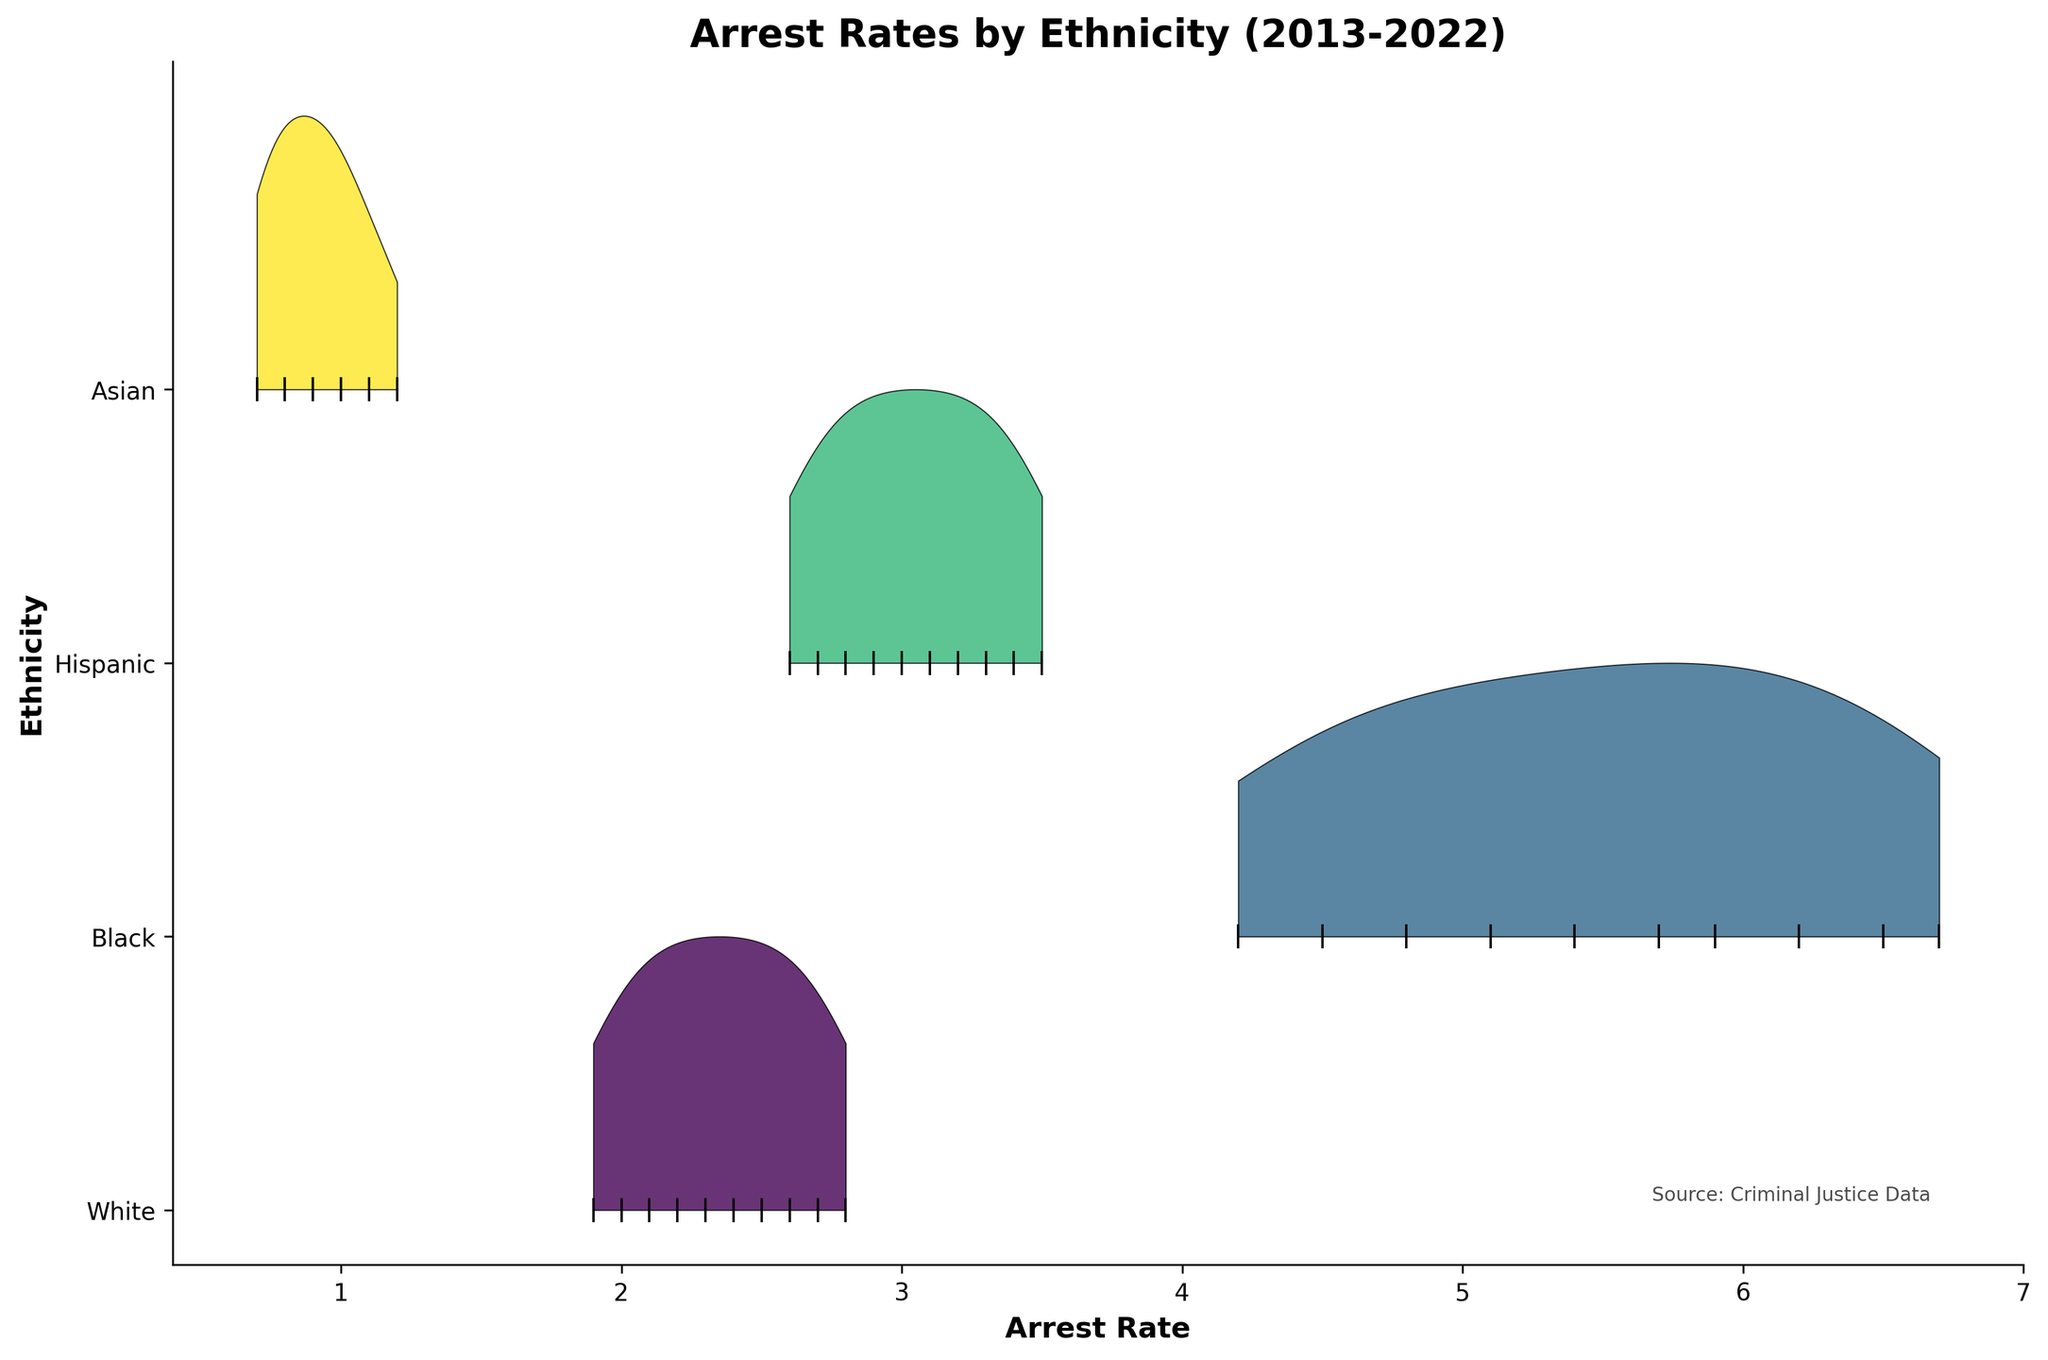What is the title of the figure? The title of the figure is displayed prominently at the top and serves as a summary of what the plot represents.
Answer: Arrest Rates by Ethnicity (2013-2022) How many ethnic groups are represented in the plot? By counting the number of unique labels on the y-axis, you can determine the number of different ethnic groups represented in the plot.
Answer: Four Which ethnic group has the highest arrest rate in 2022? By locating the year 2022 on the x-axis and checking which ethnic group has the highest arrest rate, you can identify the required group.
Answer: Black What is the arrest rate range for Hispanic ethnicity across the years? By examining the plot for the Hispanic group, you can observe the minimum and maximum arrest rates over the years.
Answer: 2.6 to 3.5 Between which years did the Black ethnic group experience the most significant decrease in arrest rates? By looking at the trend for the Black ethnic group's arrest rates on the plot, you can identify the year period with the steepest decline.
Answer: 2013 to 2014 Which ethnic group has observed the lowest variability in arrest rates over the decade? By examining the width and spread of the ridgeline plot for each ethnic group, you can conclude which has the least variability.
Answer: Asian What is the difference in arrest rates between Whites and Blacks in 2020? Locate the arrest rates for Whites and Blacks in 2020 on the plot and subtract the arrest rate for Whites from that for Blacks.
Answer: 4.8 - 2.1 = 2.7 How has the arrest rate for the Hispanic ethnic group changed from 2013 to 2022? By observing the trend line for the Hispanic ethnic group's arrest rates from 2013 to 2022 on the plot, you can determine the change.
Answer: Decreased from 3.5 to 2.6 What general trend can be observed for the arrest rates of the Asian ethnic group over the past decade? By noting the arrest rate points for the Asian ethnic group from 2013 to 2022, you can identify the overall trend.
Answer: Decreasing Which ethnic group has the greatest spread of arrest rates over the given period? By comparing the spreads (width of contours) for each ethnic group on the plot, you can identify which group has the most significant variability over the years.
Answer: Black 